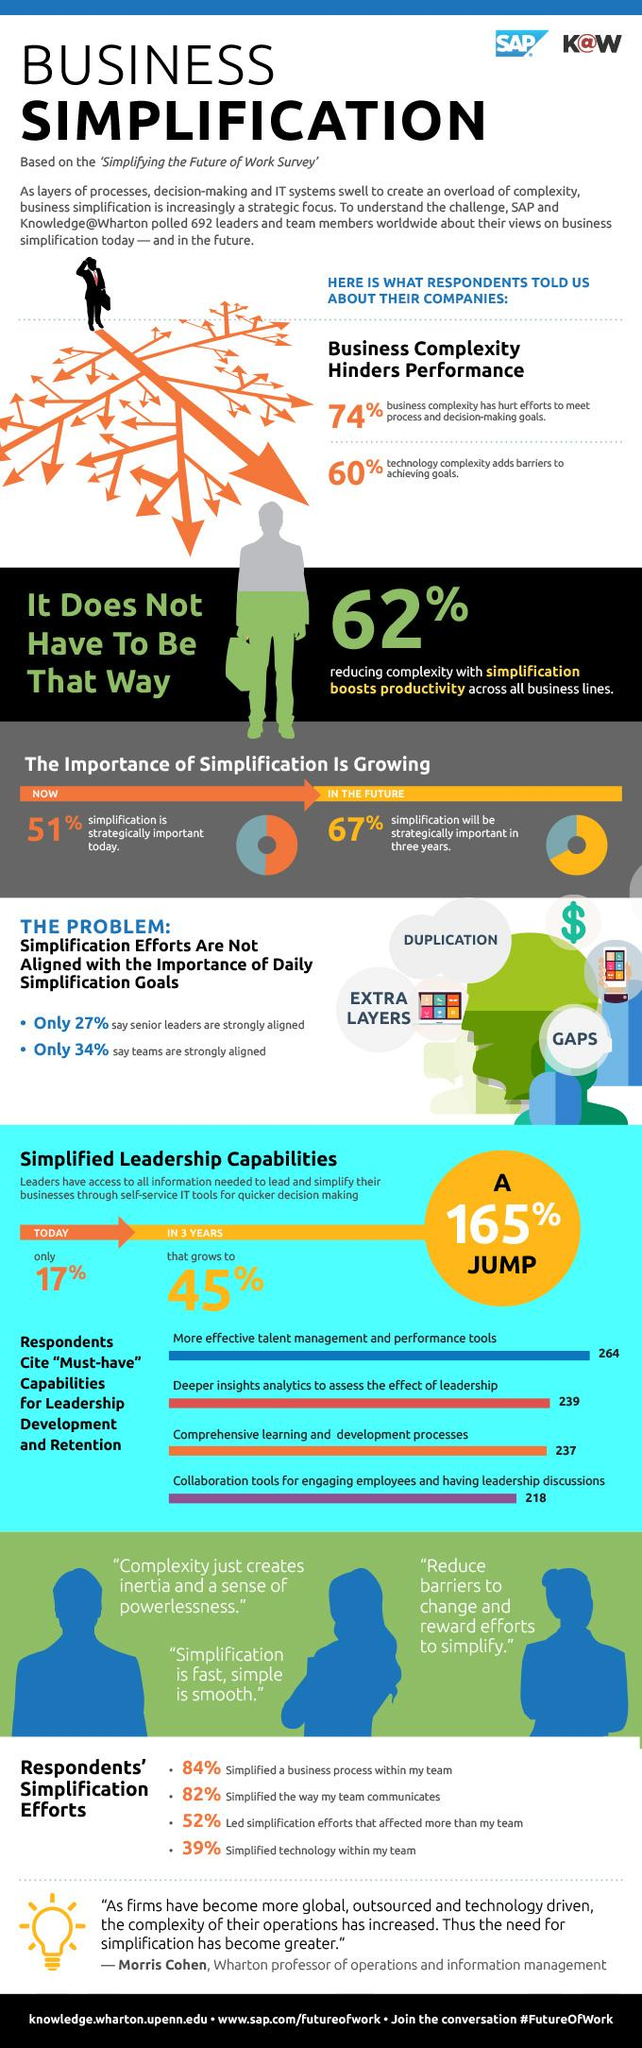Highlight a few significant elements in this photo. A majority of people, or 67%, believe that simplification is important for the future. More effective talent management and performance tools are the first capability cited by respondents as required for leadership development. According to the analysis by Deeper Insight Analytics, 239 individuals have cited the need for deeper insights into leadership effects. 